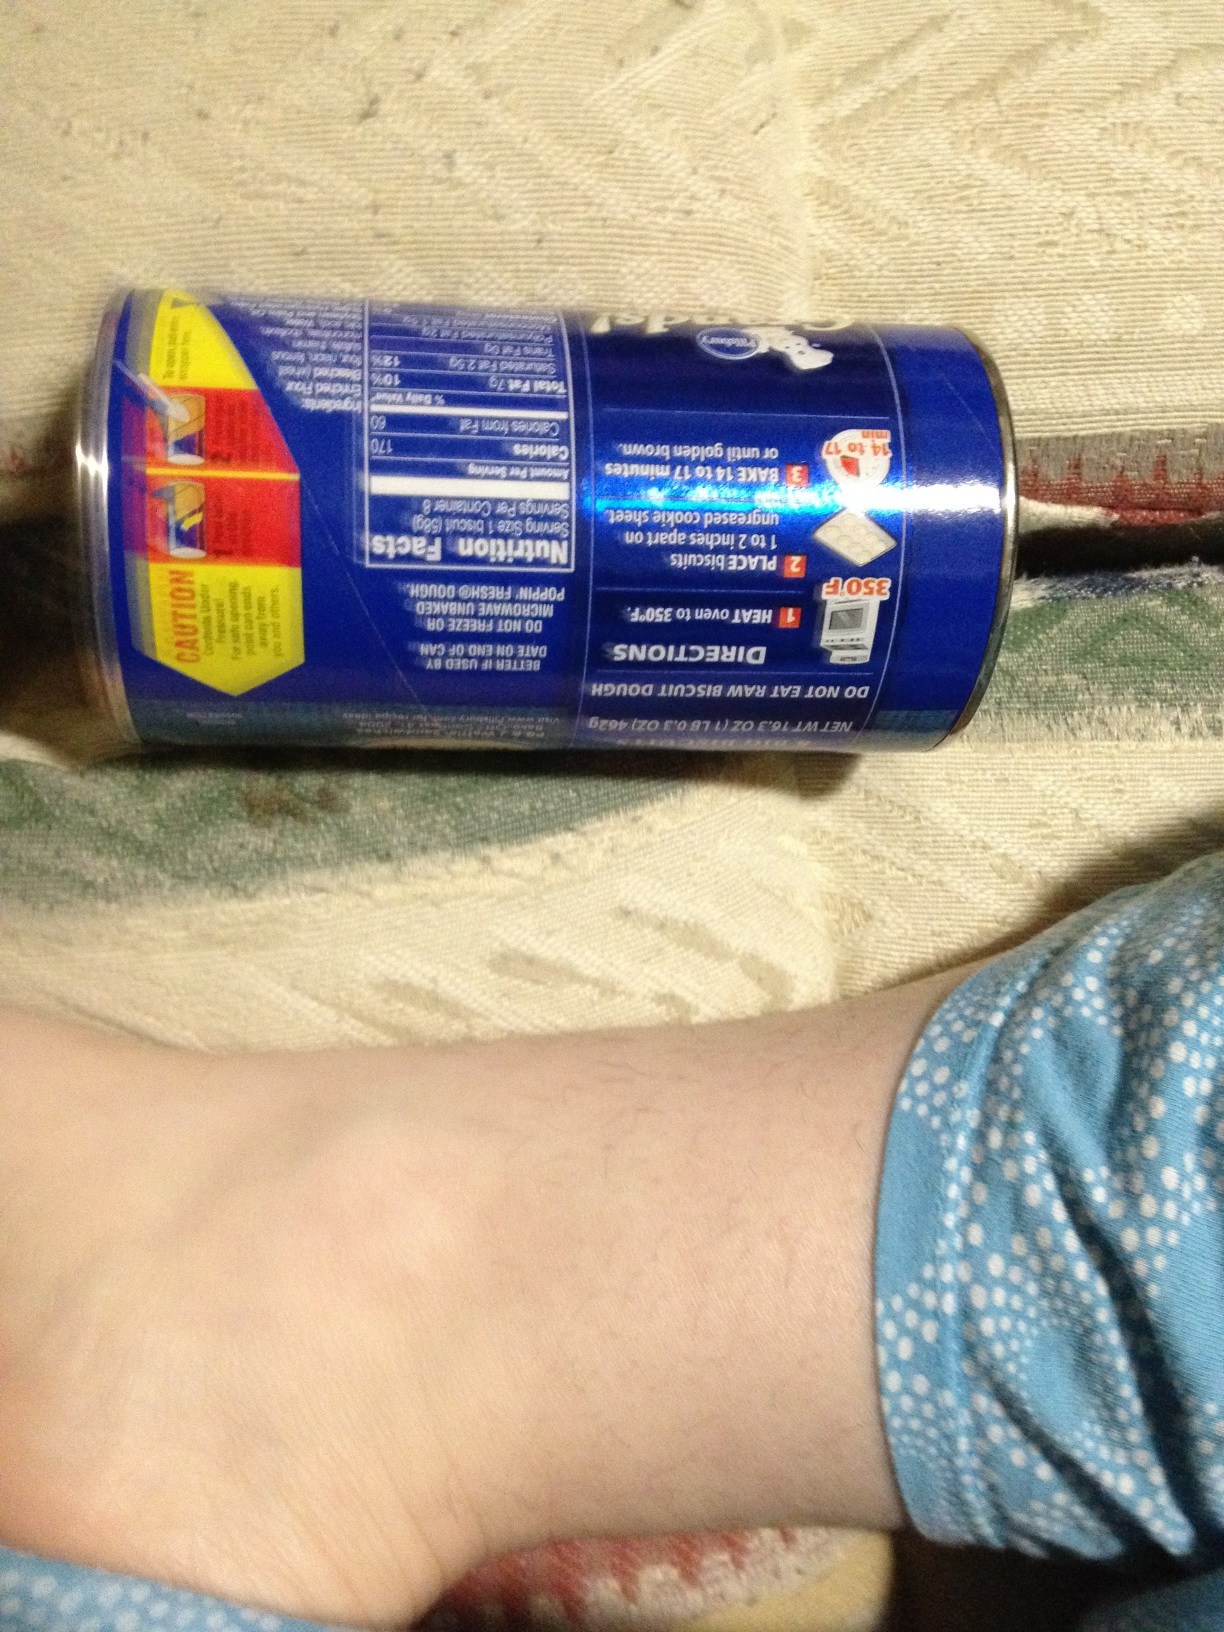Imagine you are a renowned chef about to create a new dessert dish using these biscuits. What would it be? As a renowned chef, I would create a 'Biscuit Berry Trifle,' layering freshly baked biscuits with rich vanilla custard, mixed berries like strawberries, blueberries, and raspberries, and a touch of whipped cream. Each serving would be garnished with a sprinkle of biscuit crumbs and a few mint leaves for a refreshing finish. This trifle would represent the perfect balance of sweet and tart, creamy and crunchy, a delightful dessert for any occasion. 